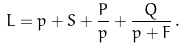Convert formula to latex. <formula><loc_0><loc_0><loc_500><loc_500>L = p + S + \frac { P } { p } + \frac { Q } { p + F } \, .</formula> 